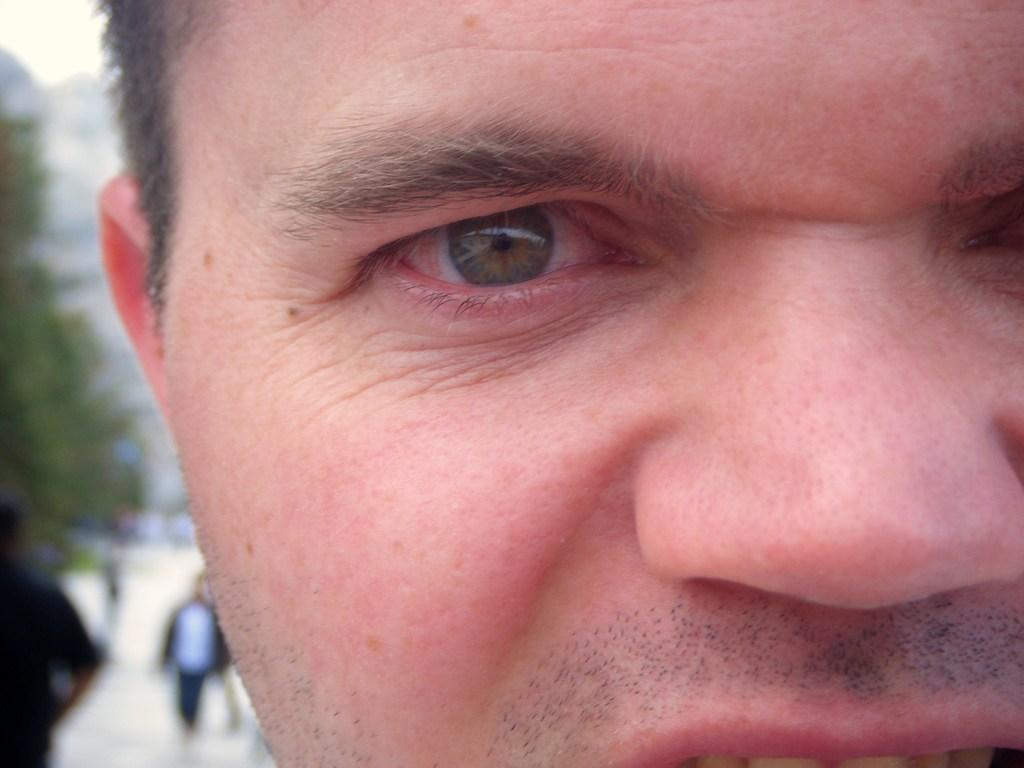What is the main subject of the image? There is a person's face in the image. Can you describe what is happening on the left side of the image? There are people on the left side of the image. What type of natural element can be seen in the image? There is a tree in the image. How would you describe the background of the image? The background of the image is blurred. How many geese are balancing on the person's tooth in the image? There are no geese or teeth present in the image, so this scenario cannot be observed. 